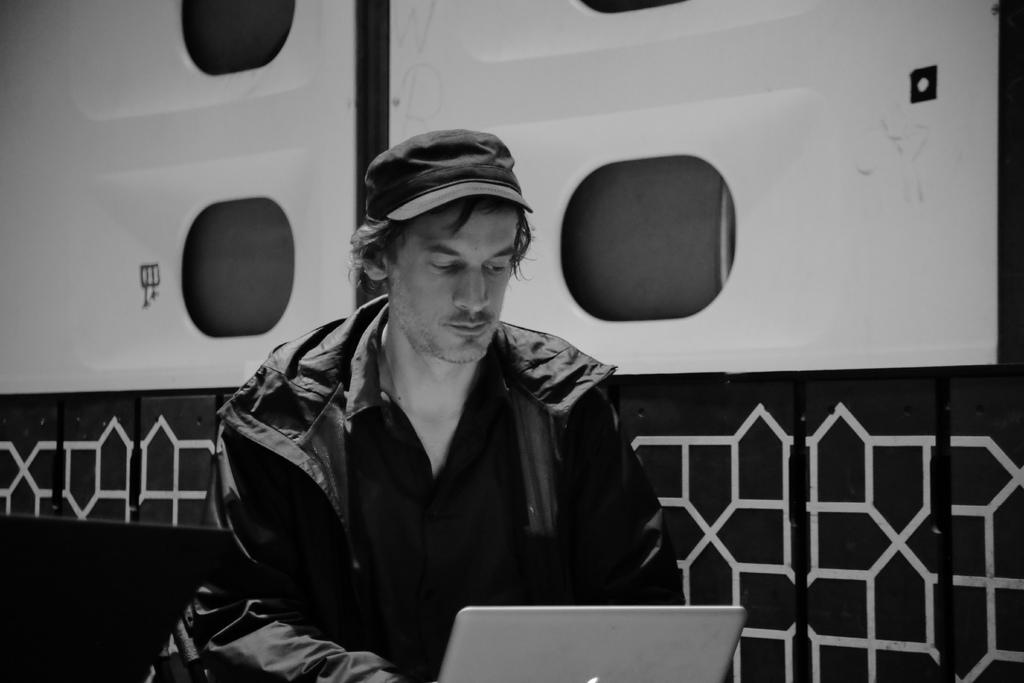What is the color scheme of the image? The image is black and white. Who or what is the main subject in the image? There is a person in the middle of the image. What is the person wearing? The person is wearing a coat. What is the person doing in the image? The person is using a laptop. Where is the laptop located in the image? The laptop is at the bottom of the image. What type of peace symbol can be seen in the image? There is no peace symbol present in the image. How many pests can be seen crawling on the person's coat in the image? There are no pests visible in the image. 